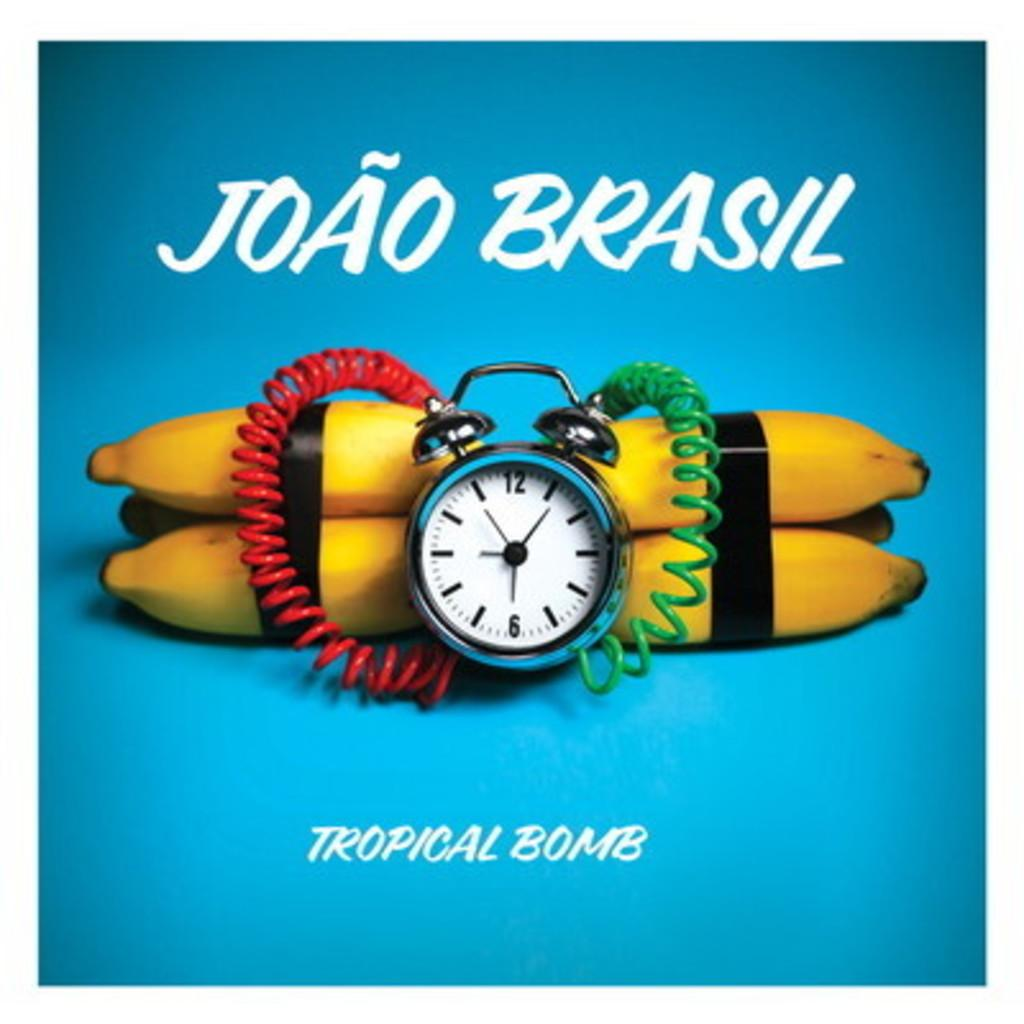<image>
Write a terse but informative summary of the picture. Joao Brasil has a product called Tropical Bomb. 